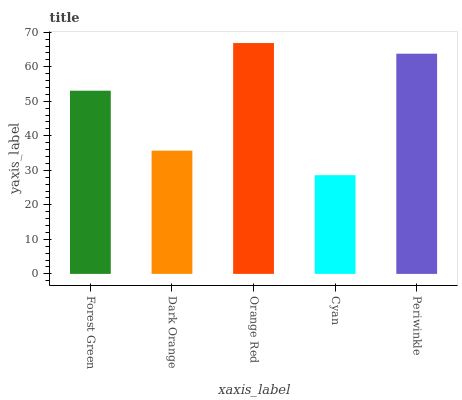Is Cyan the minimum?
Answer yes or no. Yes. Is Orange Red the maximum?
Answer yes or no. Yes. Is Dark Orange the minimum?
Answer yes or no. No. Is Dark Orange the maximum?
Answer yes or no. No. Is Forest Green greater than Dark Orange?
Answer yes or no. Yes. Is Dark Orange less than Forest Green?
Answer yes or no. Yes. Is Dark Orange greater than Forest Green?
Answer yes or no. No. Is Forest Green less than Dark Orange?
Answer yes or no. No. Is Forest Green the high median?
Answer yes or no. Yes. Is Forest Green the low median?
Answer yes or no. Yes. Is Cyan the high median?
Answer yes or no. No. Is Cyan the low median?
Answer yes or no. No. 